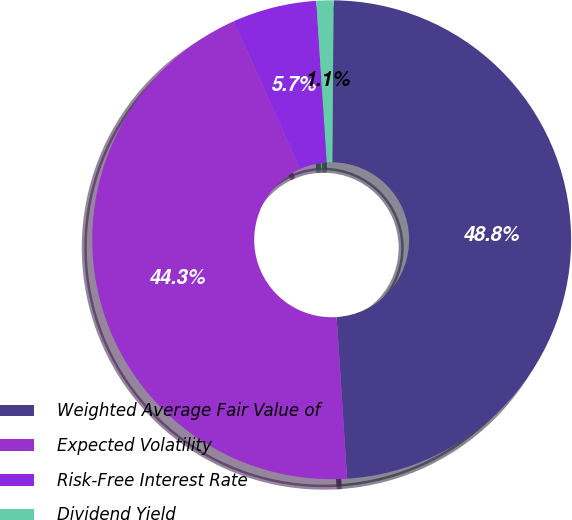Convert chart. <chart><loc_0><loc_0><loc_500><loc_500><pie_chart><fcel>Weighted Average Fair Value of<fcel>Expected Volatility<fcel>Risk-Free Interest Rate<fcel>Dividend Yield<nl><fcel>48.85%<fcel>44.32%<fcel>5.68%<fcel>1.15%<nl></chart> 